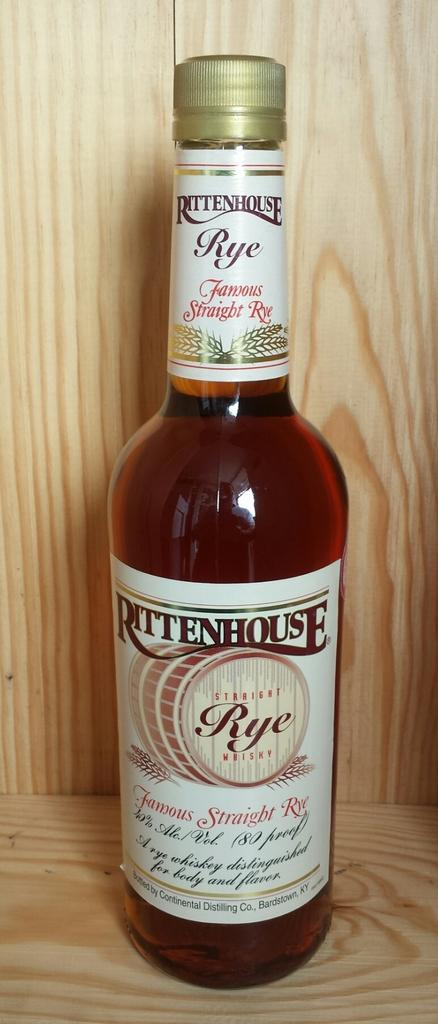What object can be seen in the image? There is a bottle in the image. What is on the bottle? There are words written on a sticker on the bottle. What type of operation is the boy performing on the bottle in the image? There is no boy present in the image, and no operation is being performed on the bottle. 